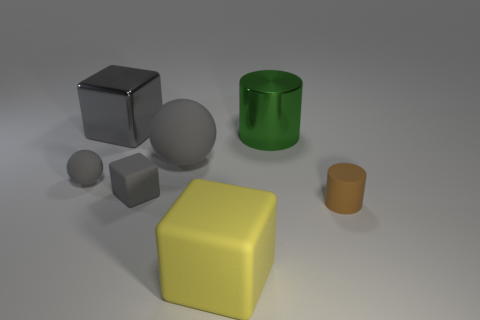Add 1 tiny gray rubber spheres. How many objects exist? 8 Subtract all balls. How many objects are left? 5 Subtract all metal blocks. Subtract all yellow rubber cubes. How many objects are left? 5 Add 2 large shiny cylinders. How many large shiny cylinders are left? 3 Add 4 big metallic things. How many big metallic things exist? 6 Subtract 0 purple blocks. How many objects are left? 7 